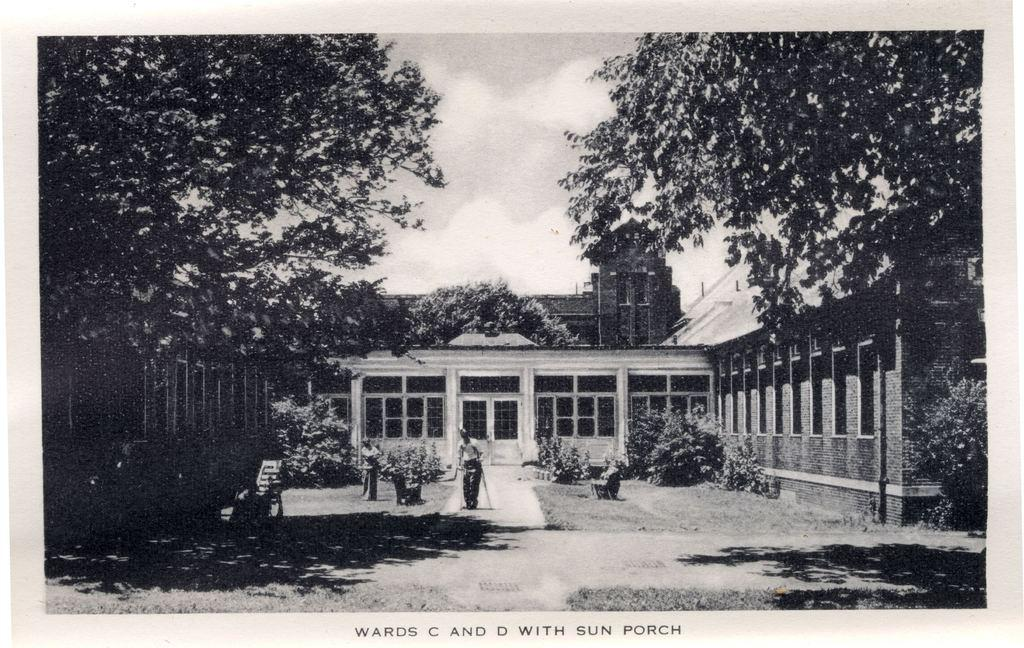<image>
Create a compact narrative representing the image presented. A black and white photo with Wards C and D with sun porch inscribed at the bottom 